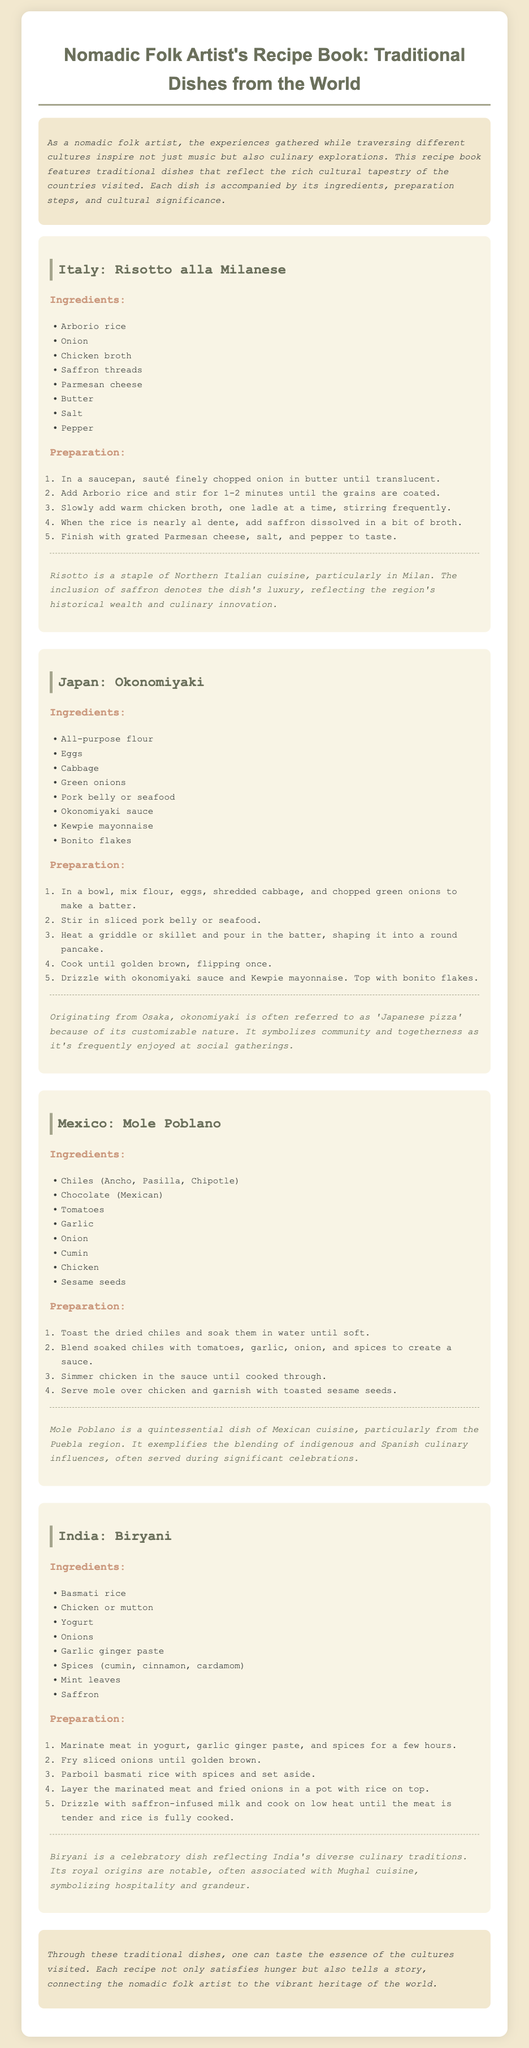What is the first recipe listed in the document? The first recipe listed is "Risotto alla Milanese," which is the title of the dish's section.
Answer: Risotto alla Milanese How many ingredients are listed for Okonomiyaki? The ingredients for Okonomiyaki are listed in a bullet format, which includes eight items.
Answer: 8 What type of cuisine is Biryani associated with? The document states that Biryani is associated with Indian cuisine, as it is described under the India section.
Answer: Indian What is the cultural significance of Mole Poblano? The significance of Mole Poblano emphasizes the blending of indigenous and Spanish culinary influences in Mexican culture, often served during celebrations.
Answer: Blending of indigenous and Spanish influences How many steps are there in the preparation of Risotto alla Milanese? The preparation steps for Risotto alla Milanese are outlined in an ordered list, which contains eight steps.
Answer: 8 